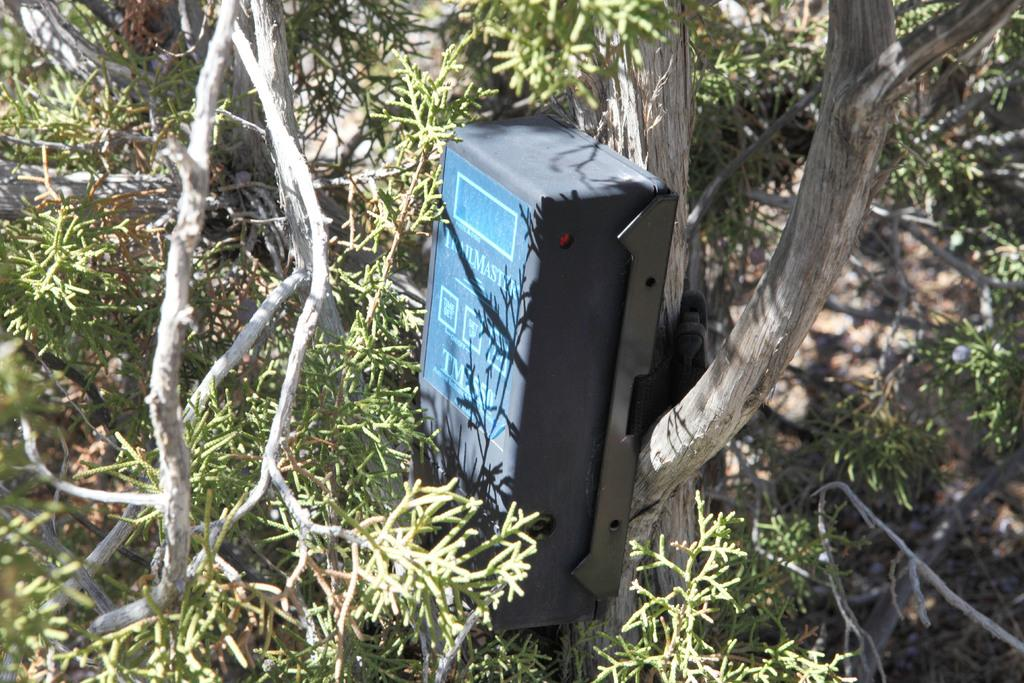What is placed on the wooden surface in the image? There is a box on a wooden surface. What type of natural elements can be seen in the image? There are branches and leaves in the image. What type of scarf is being used to provide comfort in the image? There is no scarf present in the image, and therefore no such comfort-providing activity can be observed. What type of destruction is visible in the image? There is no destruction present in the image; it features a box on a wooden surface and natural elements like branches and leaves. 